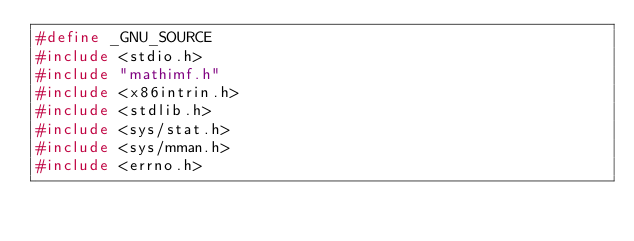<code> <loc_0><loc_0><loc_500><loc_500><_C_>#define _GNU_SOURCE
#include <stdio.h>
#include "mathimf.h"
#include <x86intrin.h>
#include <stdlib.h>
#include <sys/stat.h>
#include <sys/mman.h>
#include <errno.h></code> 